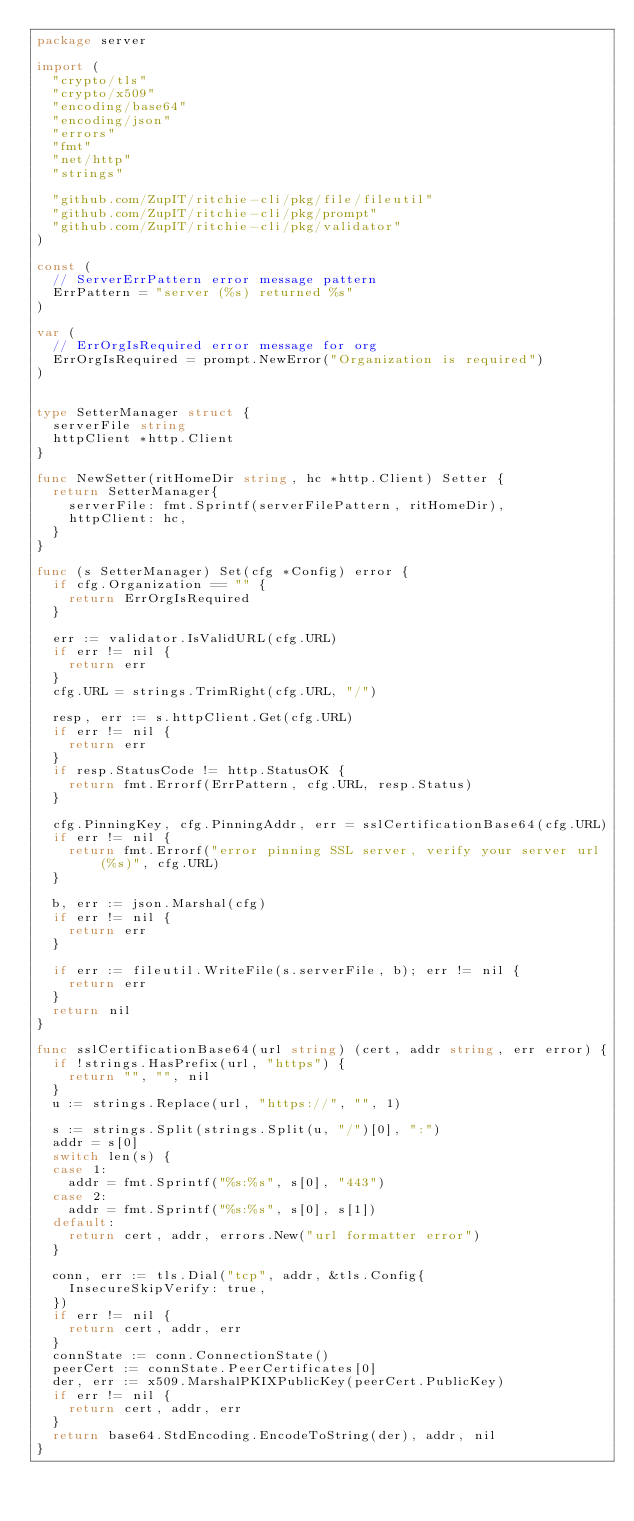Convert code to text. <code><loc_0><loc_0><loc_500><loc_500><_Go_>package server

import (
	"crypto/tls"
	"crypto/x509"
	"encoding/base64"
	"encoding/json"
	"errors"
	"fmt"
	"net/http"
	"strings"

	"github.com/ZupIT/ritchie-cli/pkg/file/fileutil"
	"github.com/ZupIT/ritchie-cli/pkg/prompt"
	"github.com/ZupIT/ritchie-cli/pkg/validator"
)

const (
	// ServerErrPattern error message pattern
	ErrPattern = "server (%s) returned %s"
)

var (
	// ErrOrgIsRequired error message for org
	ErrOrgIsRequired = prompt.NewError("Organization is required")
)


type SetterManager struct {
	serverFile string
	httpClient *http.Client
}

func NewSetter(ritHomeDir string, hc *http.Client) Setter {
	return SetterManager{
		serverFile: fmt.Sprintf(serverFilePattern, ritHomeDir),
		httpClient: hc,
	}
}

func (s SetterManager) Set(cfg *Config) error {
	if cfg.Organization == "" {
		return ErrOrgIsRequired
	}

	err := validator.IsValidURL(cfg.URL)
	if err != nil {
		return err
	}
	cfg.URL = strings.TrimRight(cfg.URL, "/")

	resp, err := s.httpClient.Get(cfg.URL)
	if err != nil {
		return err
	}
	if resp.StatusCode != http.StatusOK {
		return fmt.Errorf(ErrPattern, cfg.URL, resp.Status)
	}

	cfg.PinningKey, cfg.PinningAddr, err = sslCertificationBase64(cfg.URL)
	if err != nil {
		return fmt.Errorf("error pinning SSL server, verify your server url(%s)", cfg.URL)
	}

	b, err := json.Marshal(cfg)
	if err != nil {
		return err
	}

	if err := fileutil.WriteFile(s.serverFile, b); err != nil {
		return err
	}
	return nil
}

func sslCertificationBase64(url string) (cert, addr string, err error) {
	if !strings.HasPrefix(url, "https") {
		return "", "", nil
	}
	u := strings.Replace(url, "https://", "", 1)

	s := strings.Split(strings.Split(u, "/")[0], ":")
	addr = s[0]
	switch len(s) {
	case 1:
		addr = fmt.Sprintf("%s:%s", s[0], "443")
	case 2:
		addr = fmt.Sprintf("%s:%s", s[0], s[1])
	default:
		return cert, addr, errors.New("url formatter error")
	}

	conn, err := tls.Dial("tcp", addr, &tls.Config{
		InsecureSkipVerify: true,
	})
	if err != nil {
		return cert, addr, err
	}
	connState := conn.ConnectionState()
	peerCert := connState.PeerCertificates[0]
	der, err := x509.MarshalPKIXPublicKey(peerCert.PublicKey)
	if err != nil {
		return cert, addr, err
	}
	return base64.StdEncoding.EncodeToString(der), addr, nil
}
</code> 